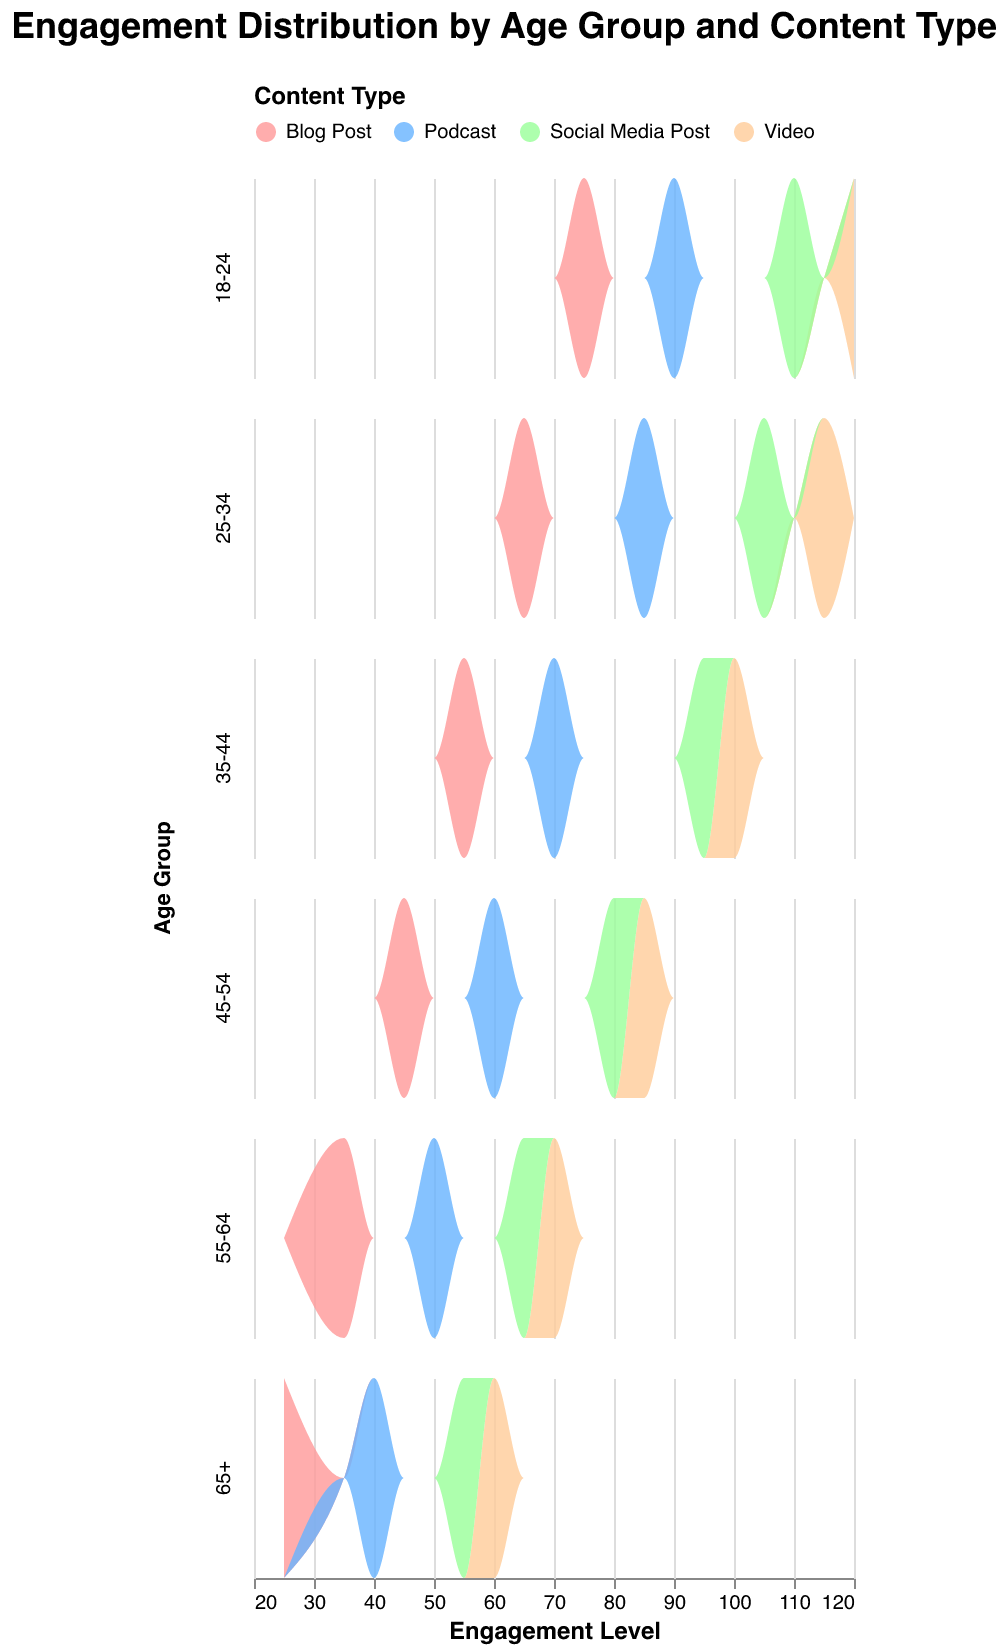Which age group has the highest engagement for videos? Looking at the density plot, the 18-24 age group shows the highest engagement level for videos at 120.
Answer: 18-24 How does the engagement level for blog posts compare between the 18-24 and 65+ age groups? The density plot shows that the engagement level for blog posts is 75 for the 18-24 age group and 25 for the 65+ age group, so the engagement is higher in the younger group.
Answer: Higher in 18-24 Which content type has the most uniformly distributed engagement levels across all age groups? Social media posts show relatively uniform engagement levels across all age groups, ranging from 55 to 110.
Answer: Social Media Posts What's the difference in engagement levels for podcasts between the 25-34 and 45-54 age groups? The density plot shows that the engagement level for podcasts is 85 for the 25-34 age group and 60 for the 45-54 age group. The difference is 85 - 60 = 25.
Answer: 25 Which age group shows the lowest engagement for social media posts? The 65+ age group shows the lowest engagement level for social media posts at 55 according to the density plot.
Answer: 65+ How do blog post engagement levels change as the age group increases from 18-24 to 55-64? The density plot shows a decreasing trend in engagement levels for blog posts: 75 (18-24), 65 (25-34), 55 (35-44), 45 (45-54), and 35 (55-64).
Answer: Decreases In which age group is the engagement level for videos closest to the engagement level for podcasts? In the 55-64 age group, the engagement level for videos is 70, and for podcasts is 50, which is the smallest gap compared to other groups.
Answer: 55-64 What is the dominant content type in terms of engagement for the 35-44 age group? The density plot shows that videos have the highest engagement level (100) in the 35-44 age group.
Answer: Videos Which age group has the smallest difference in engagement levels between podcasts and social media posts? The 65+ age group shows a small difference, with podcasts at 40 and social media posts at 55, resulting in a difference of 15.
Answer: 65+ 